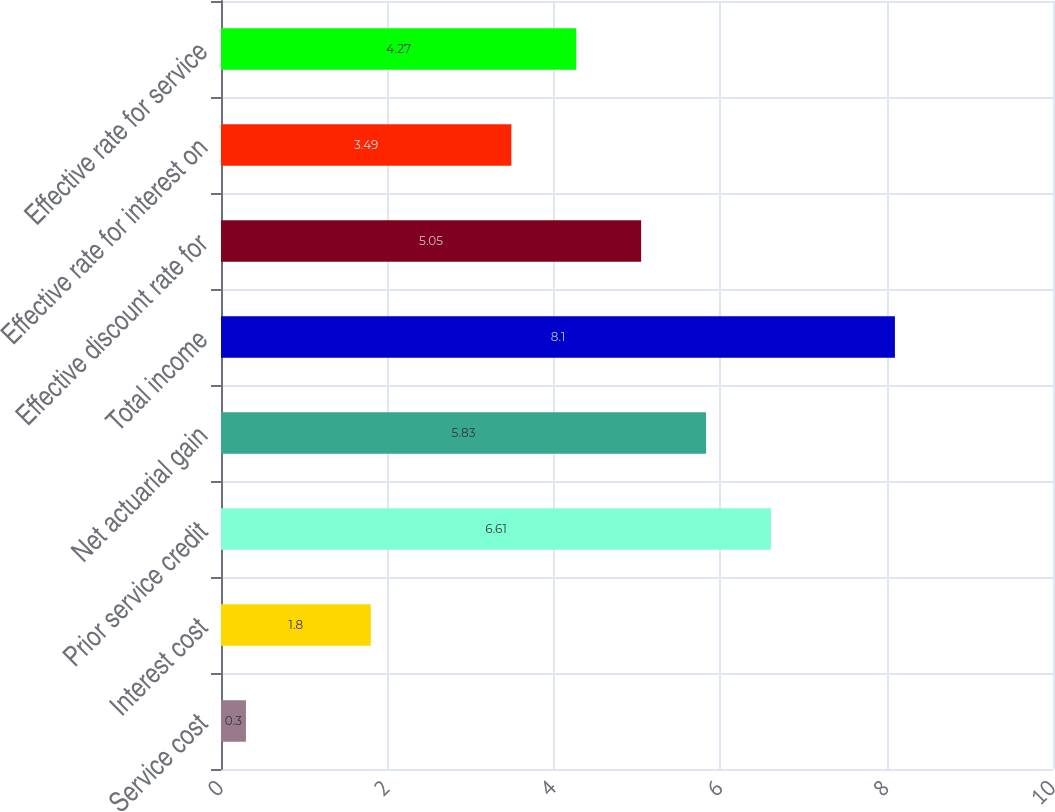Convert chart. <chart><loc_0><loc_0><loc_500><loc_500><bar_chart><fcel>Service cost<fcel>Interest cost<fcel>Prior service credit<fcel>Net actuarial gain<fcel>Total income<fcel>Effective discount rate for<fcel>Effective rate for interest on<fcel>Effective rate for service<nl><fcel>0.3<fcel>1.8<fcel>6.61<fcel>5.83<fcel>8.1<fcel>5.05<fcel>3.49<fcel>4.27<nl></chart> 